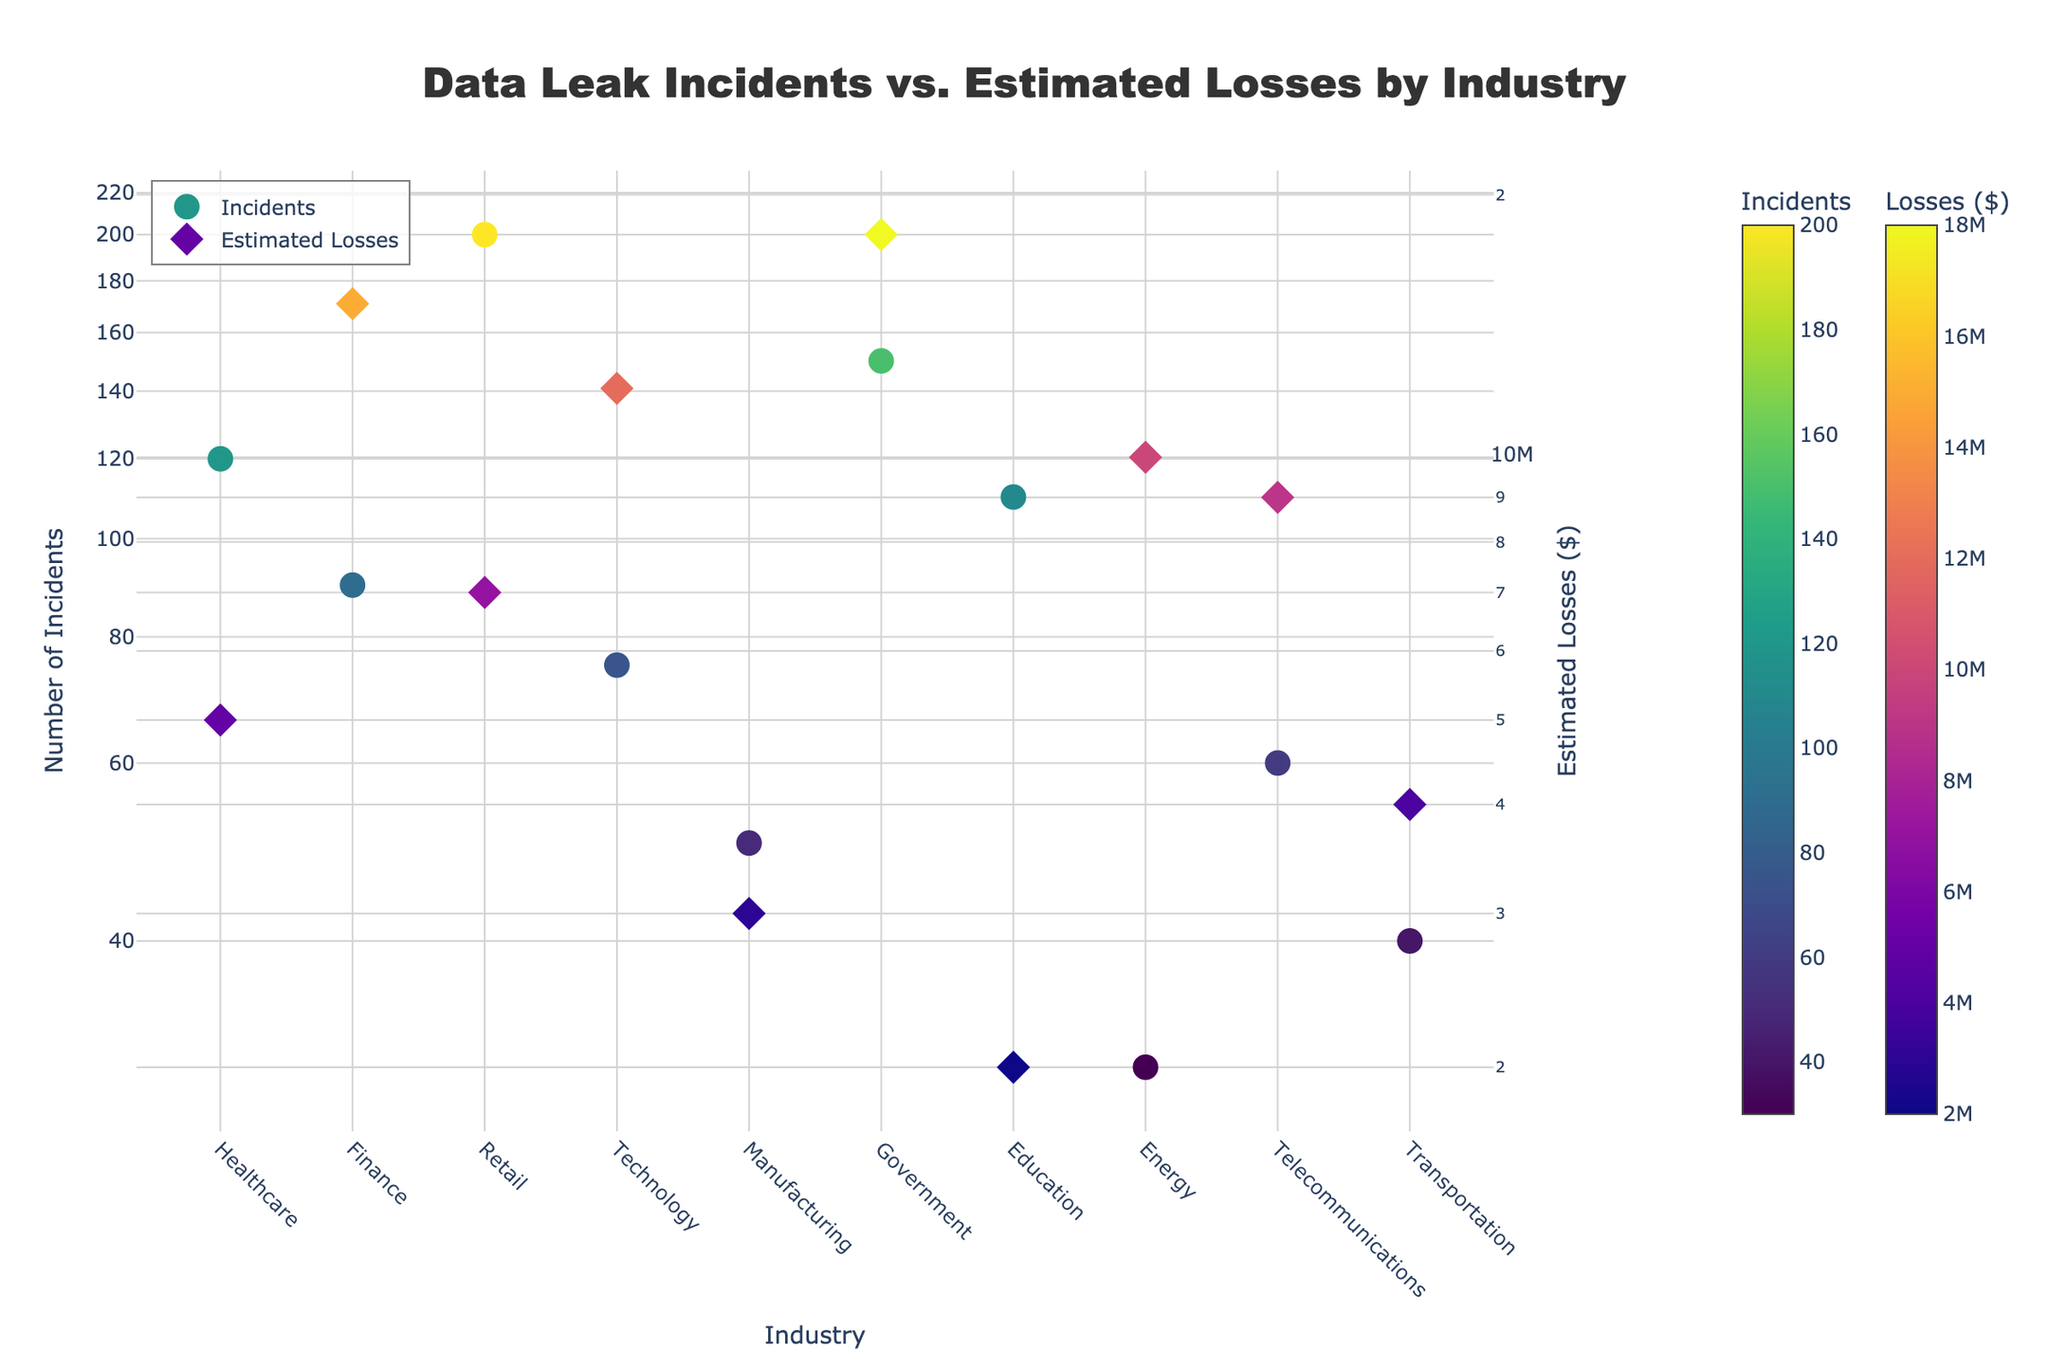What's the title of the figure? The title is usually located at the top of the figure, centered and formatted to be prominent. Look for text that is larger and bolder than other text elements.
Answer: "Data Leak Incidents vs. Estimated Losses by Industry" How many industries are represented in this scatter plot? The number of data points, each representing a unique industry, can be identified by counting the labels on the x-axis.
Answer: 10 Which industry has the highest number of data leak incidents? Examine the y-axis (left side with log scale) and find the data point with the highest value. Confirm the industry by checking the x-axis label.
Answer: Retail Which industry has the lowest estimated financial losses? Examine the y-axis (right side with log scale) and find the data point representing the lowest value. Confirm the industry by checking the x-axis label.
Answer: Education What is the relationship between incidents in Healthcare and Technology? Compare the positions of the Healthcare and Technology data points on the left y-axis (number of incidents).
Answer: Healthcare has more incidents than Technology Compare the estimated financial losses in Finance and Government industries. Look at the positions of the Finance and Government data points on the right y-axis (estimated losses).
Answer: Government has higher estimated losses than Finance Which industry stands out with the highest estimated financial losses? Examine the right y-axis and identify the data point with the highest value. Confirm the industry by checking the x-axis label.
Answer: Government What is the range of data leak incidents observed across all industries? Identify the minimum and maximum values on the left y-axis and calculate the range.
Answer: Range: 200 - 30 = 170 incidents For which industry are the incidents and estimated financial losses both below the average? Average values can be estimated visually; look for an industry where both incidents and losses are visibly below the average positions on their respective axes.
Answer: Manufacturing Are there any industries where the number of incidents is high, but the financial loss is relatively low? Compare positions of data points with high values on the left axis and relatively lower values on the right axis.
Answer: Retail 